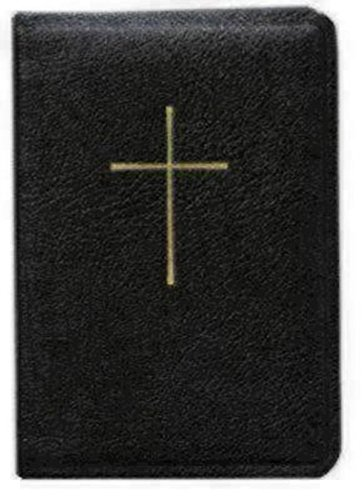Who is the author of this book? Determining the exact author of a prayer book can be complex as it may contain contributions from multiple sources over centuries, especially if it includes traditional prayers and hymns. For specific authorship, one would need to refer to the publication details inside the book. 